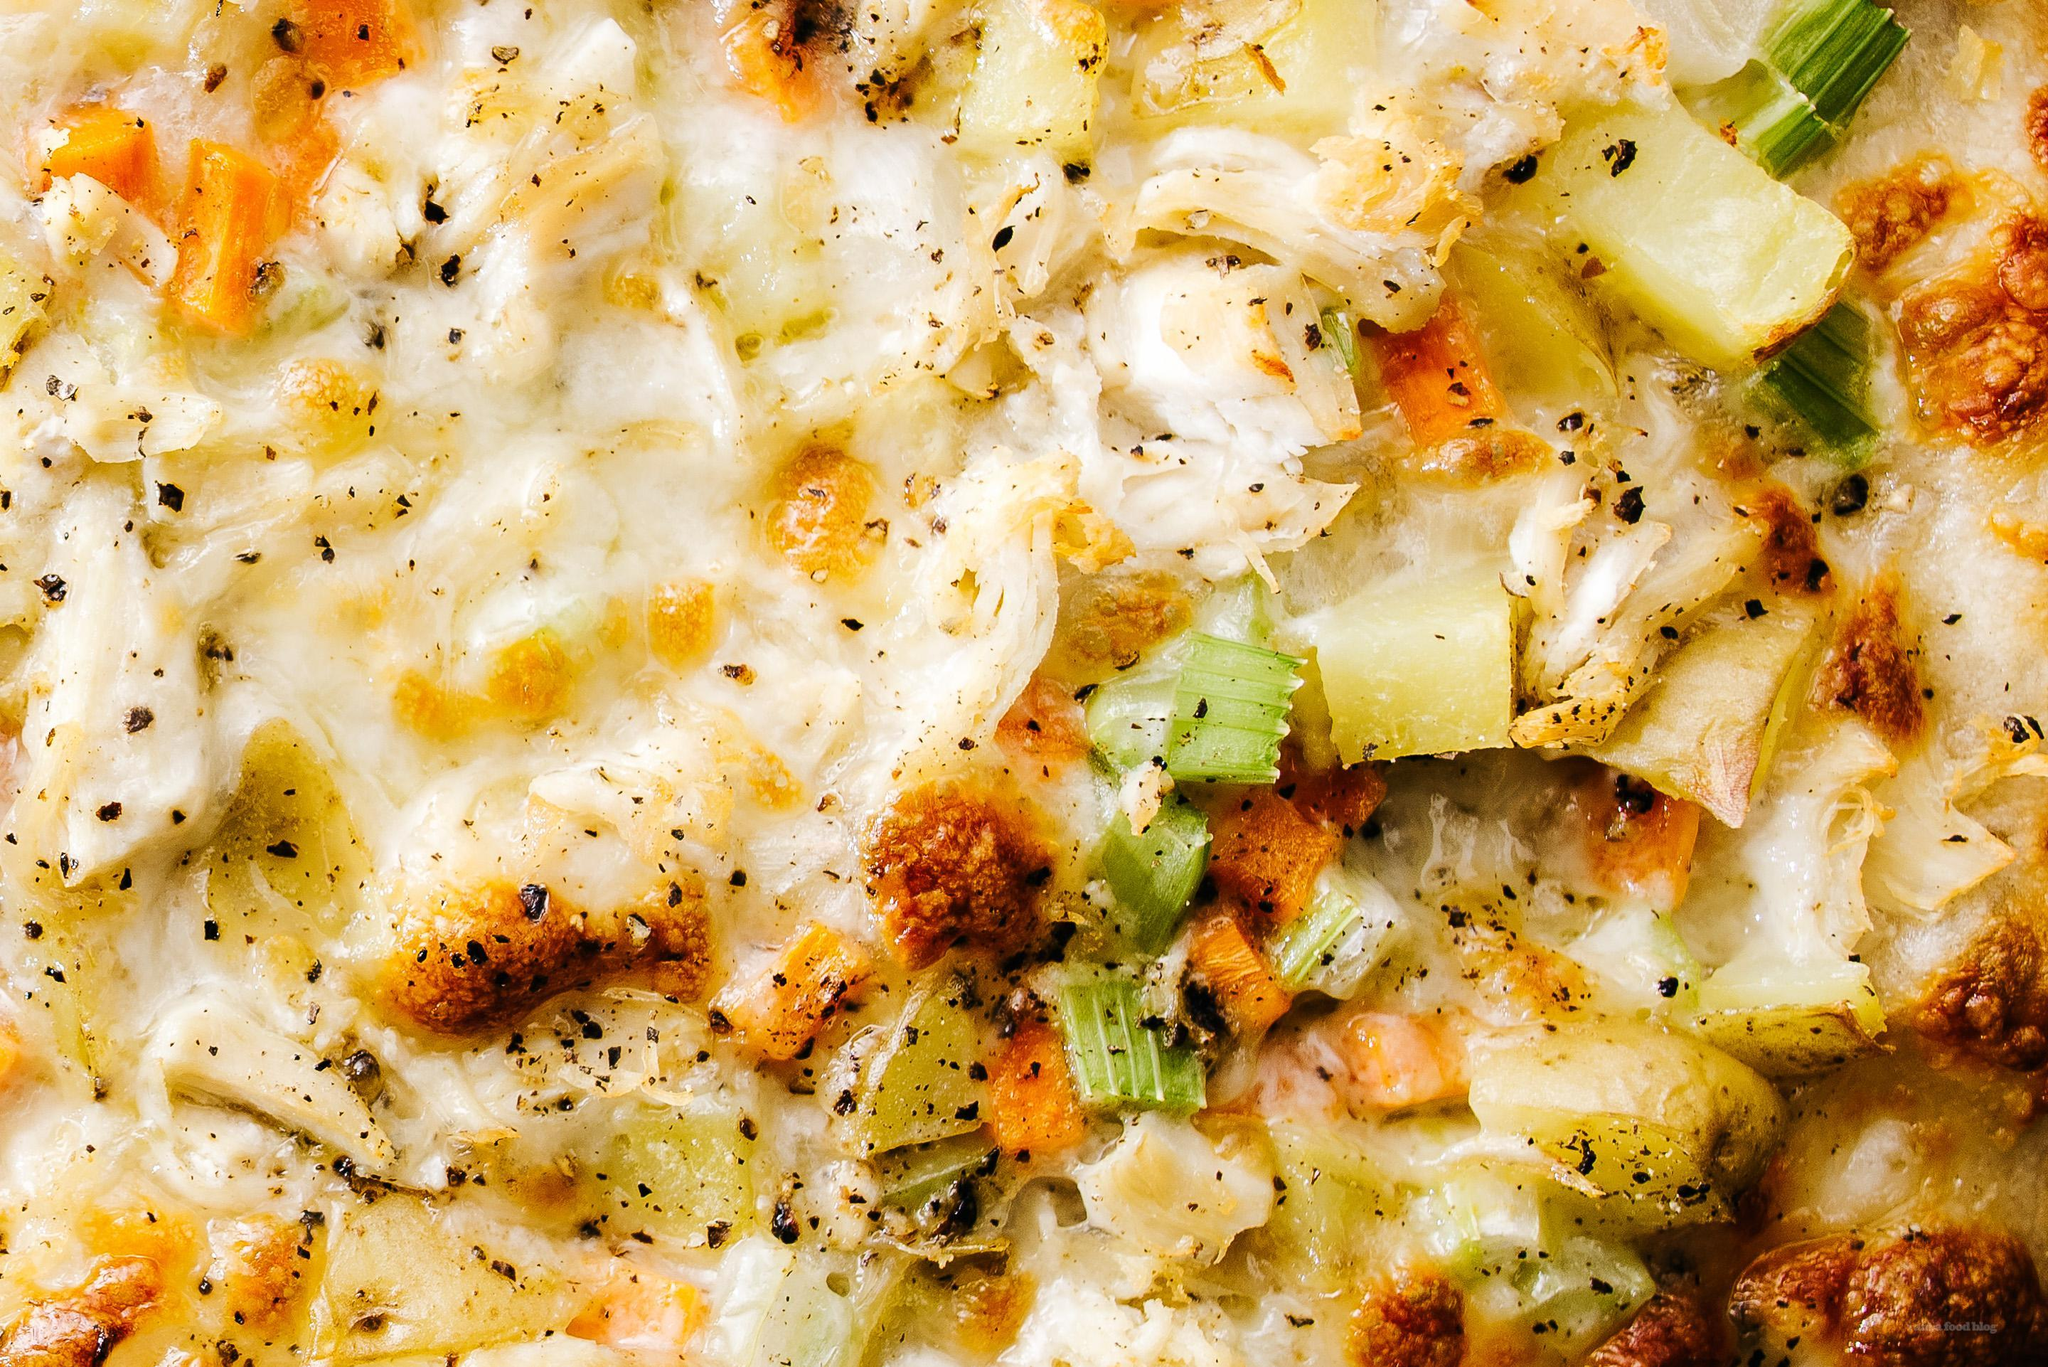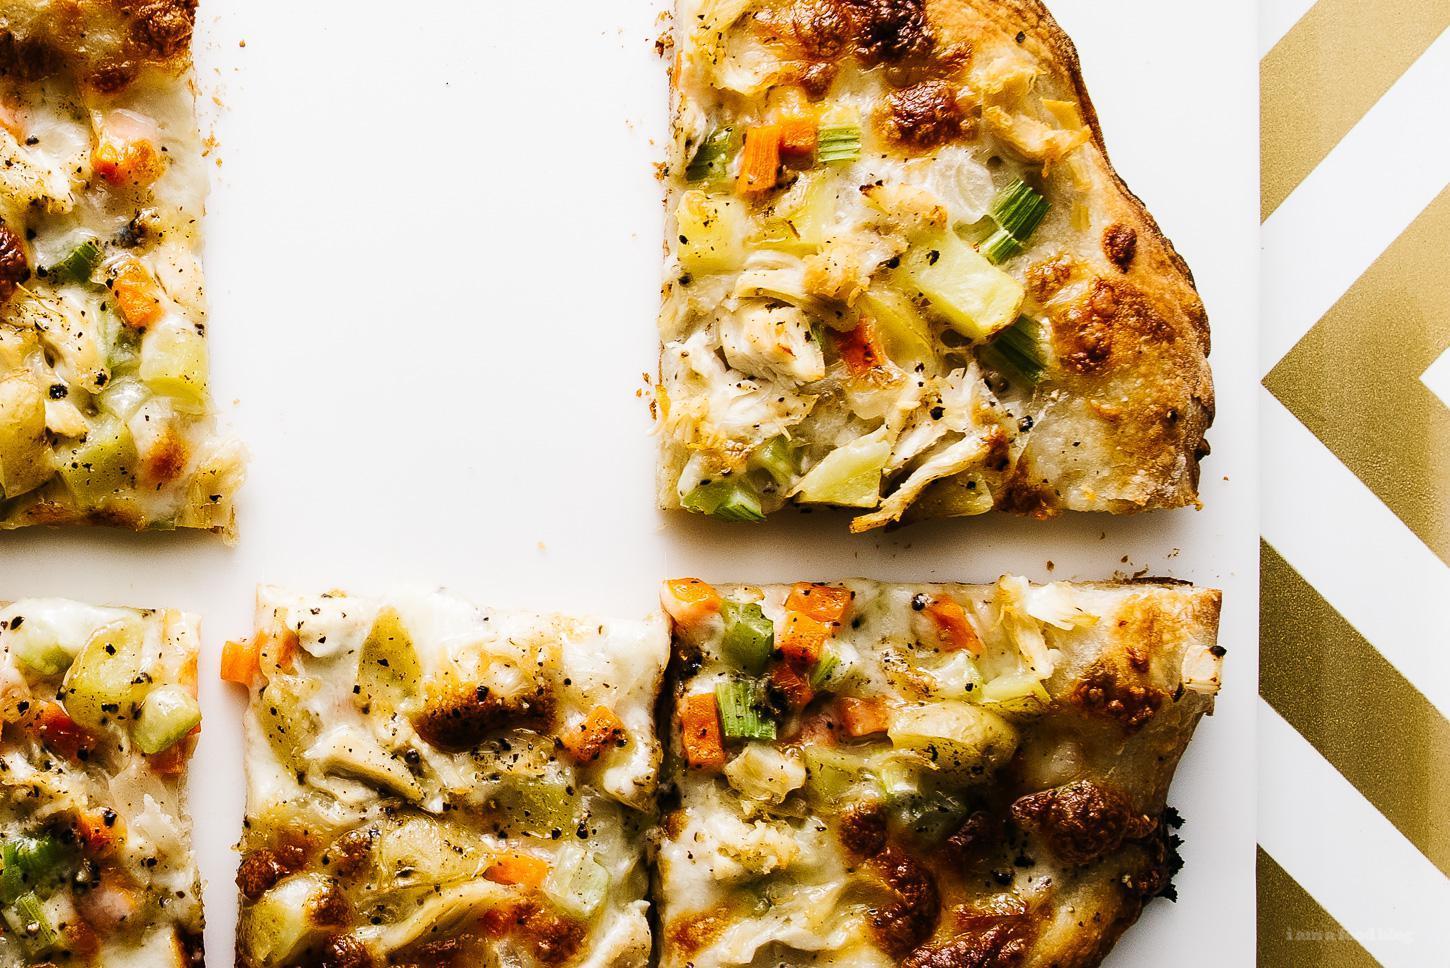The first image is the image on the left, the second image is the image on the right. Given the left and right images, does the statement "Two pizzas sit in black pans." hold true? Answer yes or no. No. 